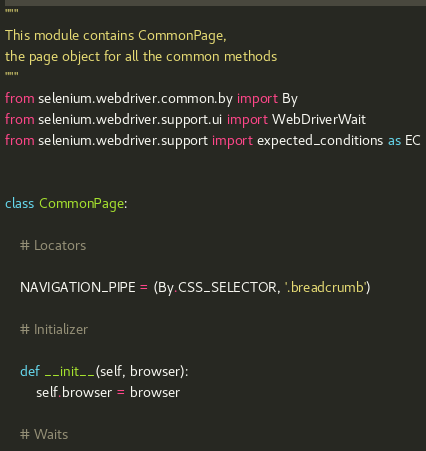Convert code to text. <code><loc_0><loc_0><loc_500><loc_500><_Python_>"""
This module contains CommonPage,
the page object for all the common methods
"""
from selenium.webdriver.common.by import By
from selenium.webdriver.support.ui import WebDriverWait
from selenium.webdriver.support import expected_conditions as EC


class CommonPage:

    # Locators

    NAVIGATION_PIPE = (By.CSS_SELECTOR, '.breadcrumb')

    # Initializer

    def __init__(self, browser):
        self.browser = browser

    # Waits
</code> 